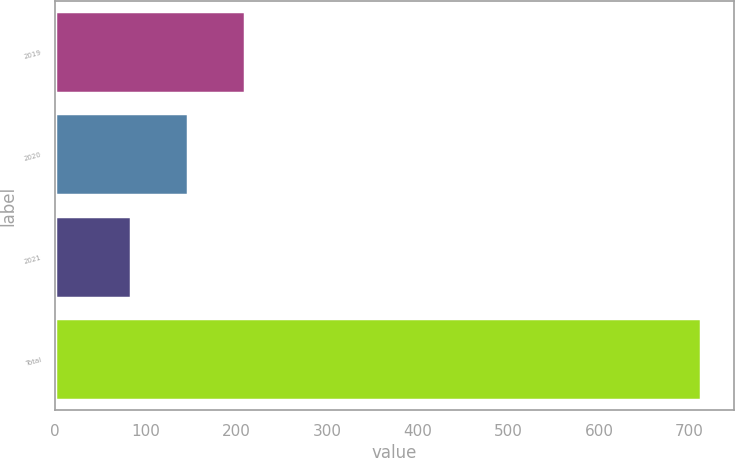<chart> <loc_0><loc_0><loc_500><loc_500><bar_chart><fcel>2019<fcel>2020<fcel>2021<fcel>Total<nl><fcel>209<fcel>146<fcel>83<fcel>713<nl></chart> 